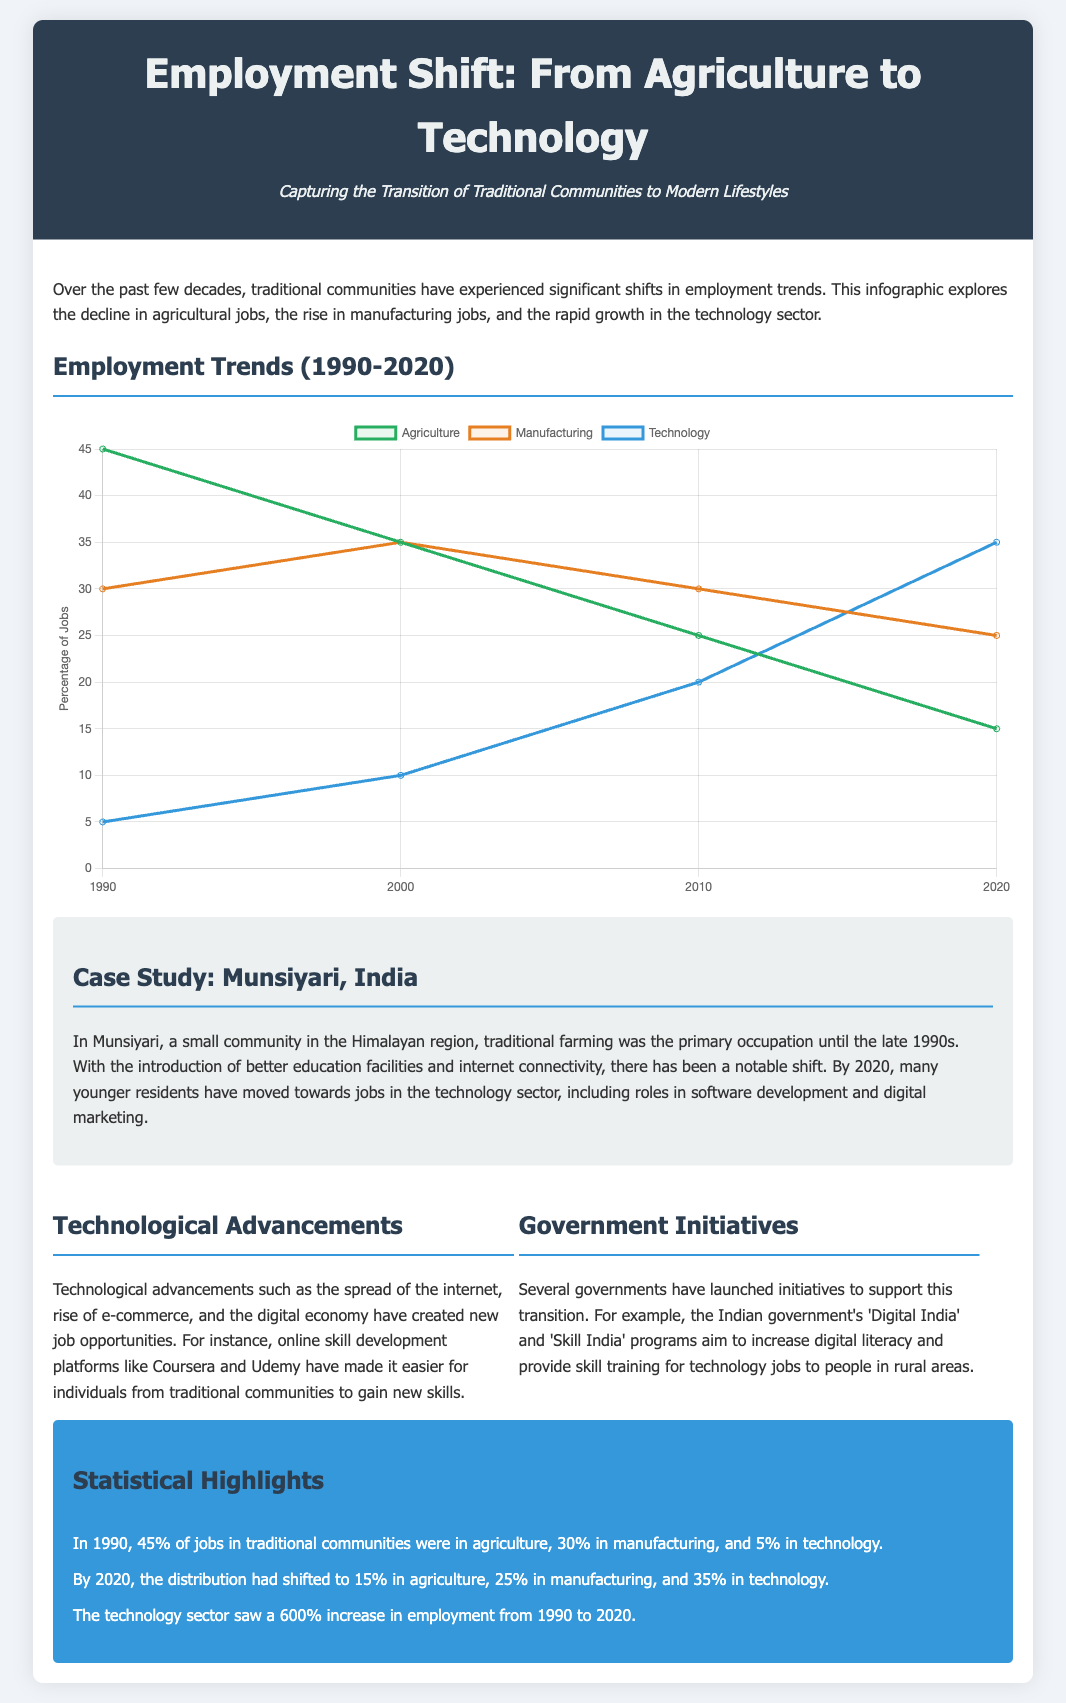what percentage of jobs were in agriculture in 1990? The document states that 45% of jobs in traditional communities were in agriculture in 1990.
Answer: 45% what was the percentage of jobs in technology by 2020? According to the document, by 2020, the percentage of jobs in technology had risen to 35%.
Answer: 35% how much did employment in the technology sector increase from 1990 to 2020? The document highlights that the technology sector saw a 600% increase in employment from 1990 to 2020.
Answer: 600% what percentage of jobs were in manufacturing in 2010? The document indicates that in 2010, 30% of jobs were in manufacturing.
Answer: 30% which community is used as a case study in the document? The case study presented in the document focuses on Munsiyari, India.
Answer: Munsiyari, India what initiative does the Indian government have for increasing digital literacy? The document mentions the 'Digital India' initiative aimed at increasing digital literacy.
Answer: Digital India which sector had the lowest employment in 1990? The document notes that the technology sector had the lowest employment in 1990, with 5%.
Answer: Technology what was the percentage of jobs in agriculture by 2020? By 2020, the percentage of jobs in agriculture had dropped to 15%.
Answer: 15% what color represents the technology sector in the chart? The color representing the technology sector in the chart is blue (#3498db).
Answer: Blue 